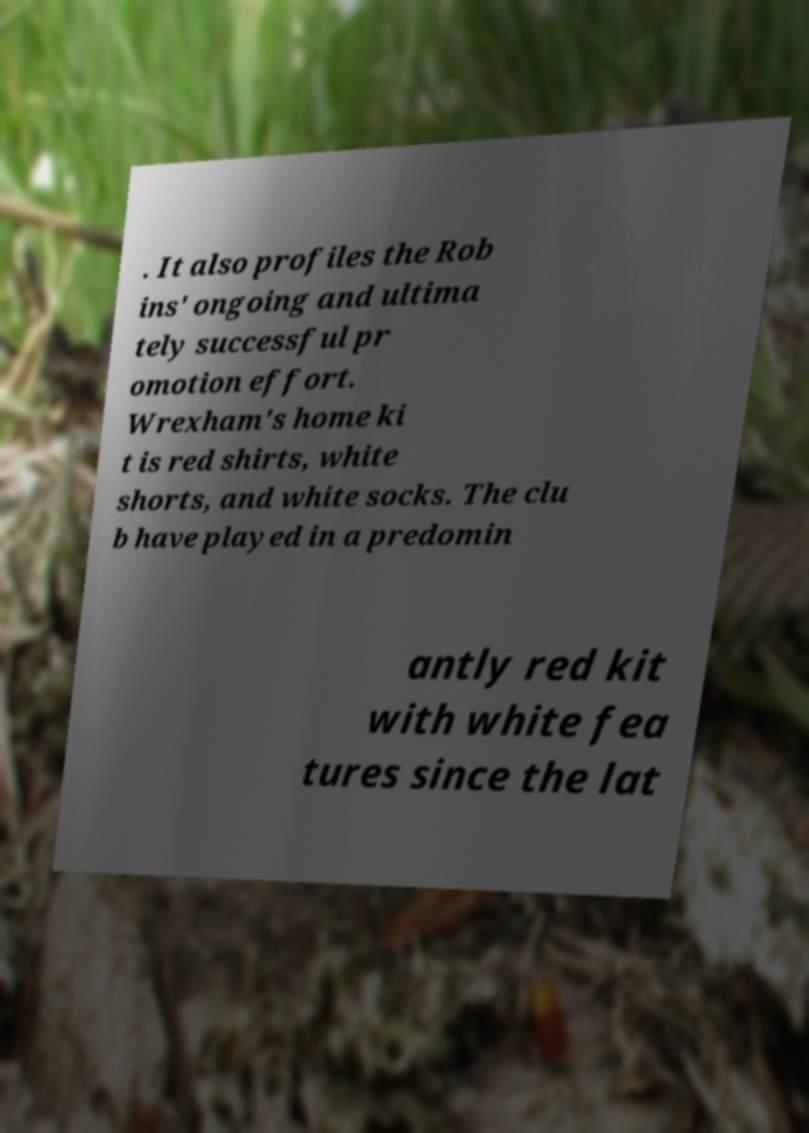Please read and relay the text visible in this image. What does it say? . It also profiles the Rob ins' ongoing and ultima tely successful pr omotion effort. Wrexham's home ki t is red shirts, white shorts, and white socks. The clu b have played in a predomin antly red kit with white fea tures since the lat 